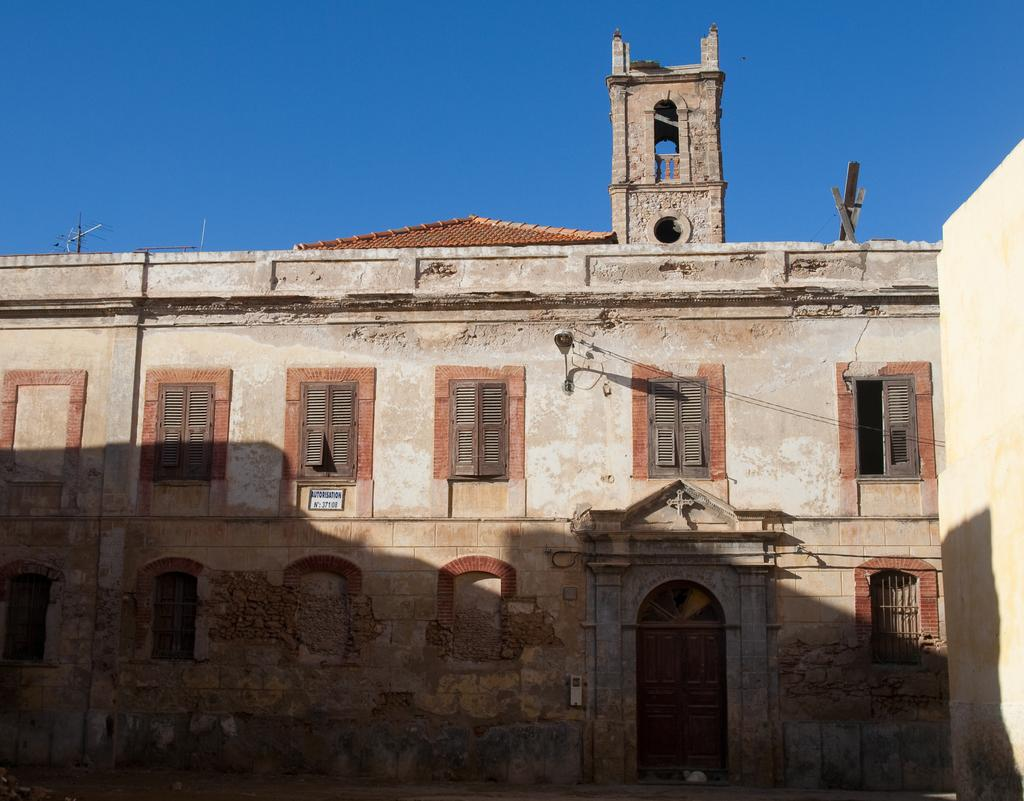What type of structure is present in the image? There is a building in the image. What object can be seen near the building? There is a board in the image. What can be used to illuminate the area in the image? There is a light in the image. What is the tall, vertical object in the image? There is a pole in the image. What can be seen in the distance in the image? The sky is visible in the background of the image. What type of knee is visible in the image? There is no knee present in the image. What form of partnership is depicted in the image? There is no partnership depicted in the image; it features a building, board, light, pole, and sky. 